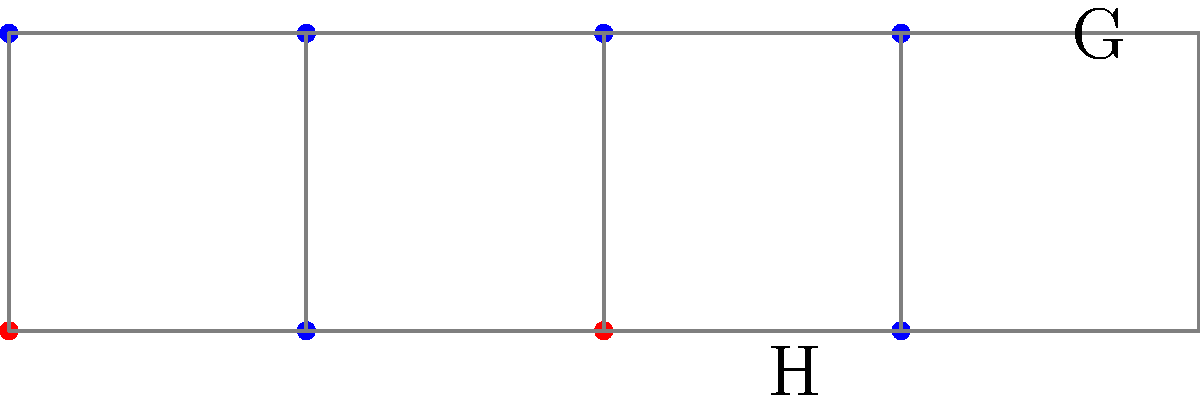In the diagram above, a group $G$ is represented by blue dots, and its subgroup $H$ is represented by red dots. The cosets of $H$ in $G$ are visualized as partitions of the larger set $G$. How many distinct left cosets of $H$ in $G$ are there, and what does this number represent in terms of group theory? To solve this problem, let's follow these steps:

1) First, recall that the number of distinct left cosets of a subgroup $H$ in a group $G$ is equal to the index of $H$ in $G$, denoted as $[G:H]$.

2) The index $[G:H]$ is also equal to the order of $G$ divided by the order of $H$:

   $[G:H] = \frac{|G|}{|H|}$

3) From the diagram, we can count:
   - $|G| = 8$ (total number of blue dots)
   - $|H| = 2$ (number of red dots)

4) Therefore, $[G:H] = \frac{8}{2} = 4$

5) We can visually confirm this in the diagram: there are 4 distinct rectangles, each containing 2 elements. These rectangles represent the cosets.

6) In group theory, this number (4) represents:
   a) The number of distinct left cosets of $H$ in $G$
   b) The number of distinct right cosets of $H$ in $G$ (as they are the same for subgroups)
   c) The order of the quotient group $G/H$

7) Each coset contains $|H| = 2$ elements, and there are 4 cosets, which together make up all 8 elements of $G$.
Answer: 4 distinct left cosets; represents index $[G:H]$ and order of quotient group $G/H$ 